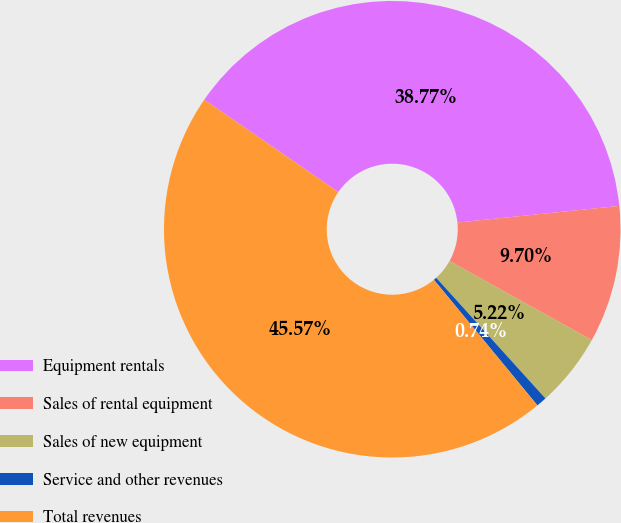Convert chart to OTSL. <chart><loc_0><loc_0><loc_500><loc_500><pie_chart><fcel>Equipment rentals<fcel>Sales of rental equipment<fcel>Sales of new equipment<fcel>Service and other revenues<fcel>Total revenues<nl><fcel>38.77%<fcel>9.7%<fcel>5.22%<fcel>0.74%<fcel>45.57%<nl></chart> 